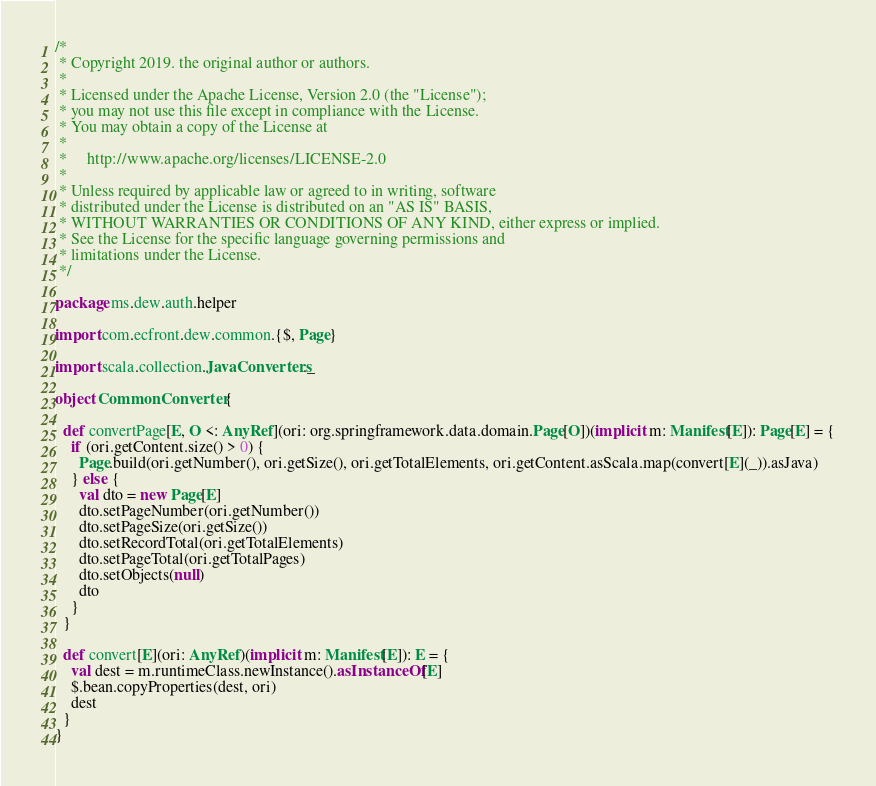<code> <loc_0><loc_0><loc_500><loc_500><_Scala_>/*
 * Copyright 2019. the original author or authors.
 *
 * Licensed under the Apache License, Version 2.0 (the "License");
 * you may not use this file except in compliance with the License.
 * You may obtain a copy of the License at
 *
 *     http://www.apache.org/licenses/LICENSE-2.0
 *
 * Unless required by applicable law or agreed to in writing, software
 * distributed under the License is distributed on an "AS IS" BASIS,
 * WITHOUT WARRANTIES OR CONDITIONS OF ANY KIND, either express or implied.
 * See the License for the specific language governing permissions and
 * limitations under the License.
 */

package ms.dew.auth.helper

import com.ecfront.dew.common.{$, Page}

import scala.collection.JavaConverters._

object CommonConverter {

  def convertPage[E, O <: AnyRef](ori: org.springframework.data.domain.Page[O])(implicit m: Manifest[E]): Page[E] = {
    if (ori.getContent.size() > 0) {
      Page.build(ori.getNumber(), ori.getSize(), ori.getTotalElements, ori.getContent.asScala.map(convert[E](_)).asJava)
    } else {
      val dto = new Page[E]
      dto.setPageNumber(ori.getNumber())
      dto.setPageSize(ori.getSize())
      dto.setRecordTotal(ori.getTotalElements)
      dto.setPageTotal(ori.getTotalPages)
      dto.setObjects(null)
      dto
    }
  }

  def convert[E](ori: AnyRef)(implicit m: Manifest[E]): E = {
    val dest = m.runtimeClass.newInstance().asInstanceOf[E]
    $.bean.copyProperties(dest, ori)
    dest
  }
}
</code> 